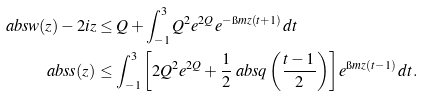Convert formula to latex. <formula><loc_0><loc_0><loc_500><loc_500>\ a b s { w ( z ) - 2 i z } & \leq Q + \int _ { - 1 } ^ { 3 } Q ^ { 2 } e ^ { 2 Q } e ^ { - \i m z ( t + 1 ) } \, d t \\ \ a b s { s ( z ) } & \leq \int _ { - 1 } ^ { 3 } \left [ 2 Q ^ { 2 } e ^ { 2 Q } + \frac { 1 } { 2 } \ a b s { q \left ( \frac { t - 1 } { 2 } \right ) } \right ] e ^ { \i m z ( t - 1 ) } \, d t .</formula> 